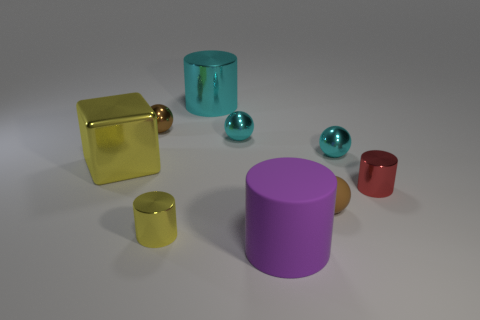There is a shiny cylinder that is the same color as the large cube; what is its size?
Your answer should be compact. Small. Is there a gray shiny cylinder of the same size as the yellow cylinder?
Your response must be concise. No. Does the yellow cylinder have the same material as the cyan object on the right side of the purple object?
Provide a succinct answer. Yes. Are there more metallic objects than small red cylinders?
Give a very brief answer. Yes. How many blocks are either big purple rubber things or small cyan shiny objects?
Provide a succinct answer. 0. What color is the tiny matte thing?
Give a very brief answer. Brown. There is a brown object that is on the right side of the large cyan object; is its size the same as the cylinder in front of the small yellow shiny cylinder?
Keep it short and to the point. No. Is the number of yellow objects less than the number of small metal objects?
Keep it short and to the point. Yes. How many yellow blocks are right of the big cyan metal cylinder?
Offer a terse response. 0. What is the big cyan thing made of?
Offer a terse response. Metal. 